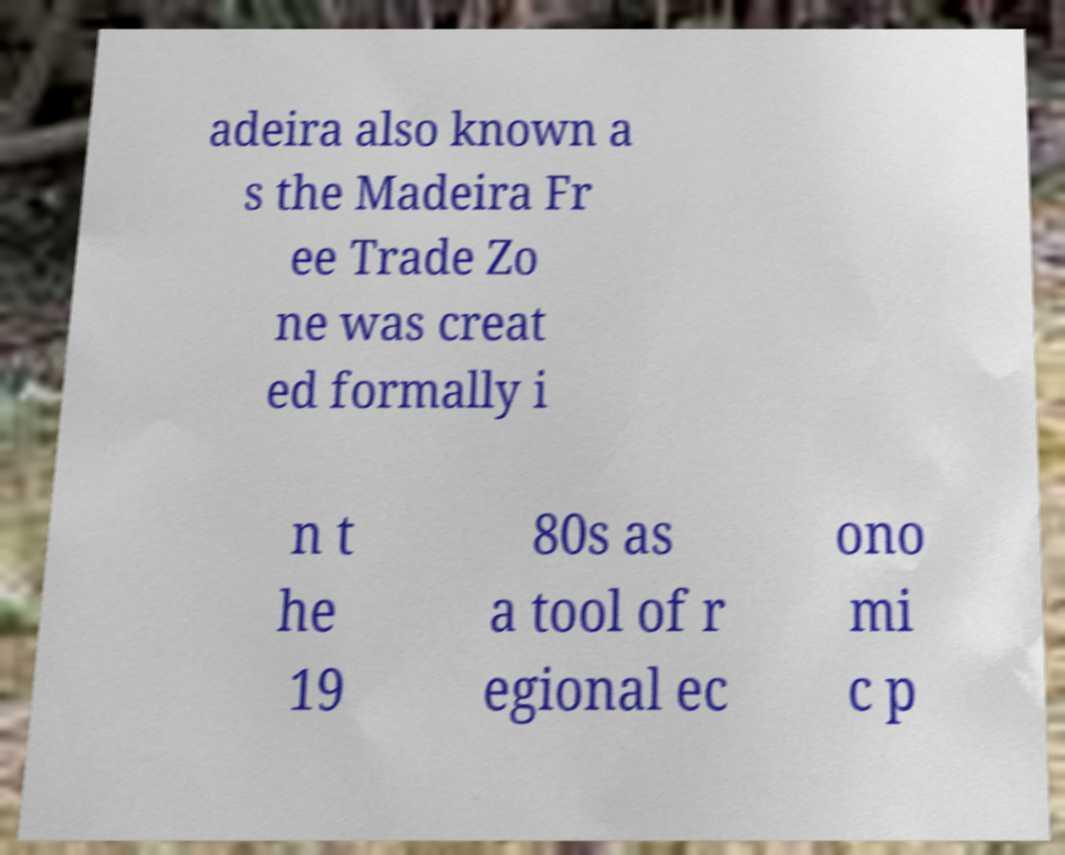There's text embedded in this image that I need extracted. Can you transcribe it verbatim? adeira also known a s the Madeira Fr ee Trade Zo ne was creat ed formally i n t he 19 80s as a tool of r egional ec ono mi c p 